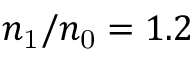<formula> <loc_0><loc_0><loc_500><loc_500>n _ { 1 } / n _ { 0 } = 1 . 2</formula> 